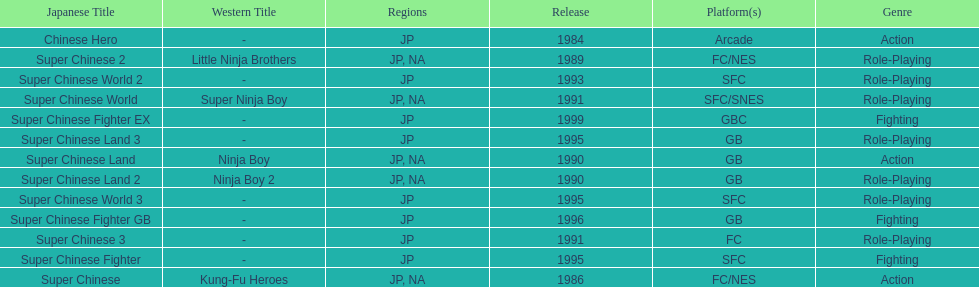Number of super chinese world games released 3. 